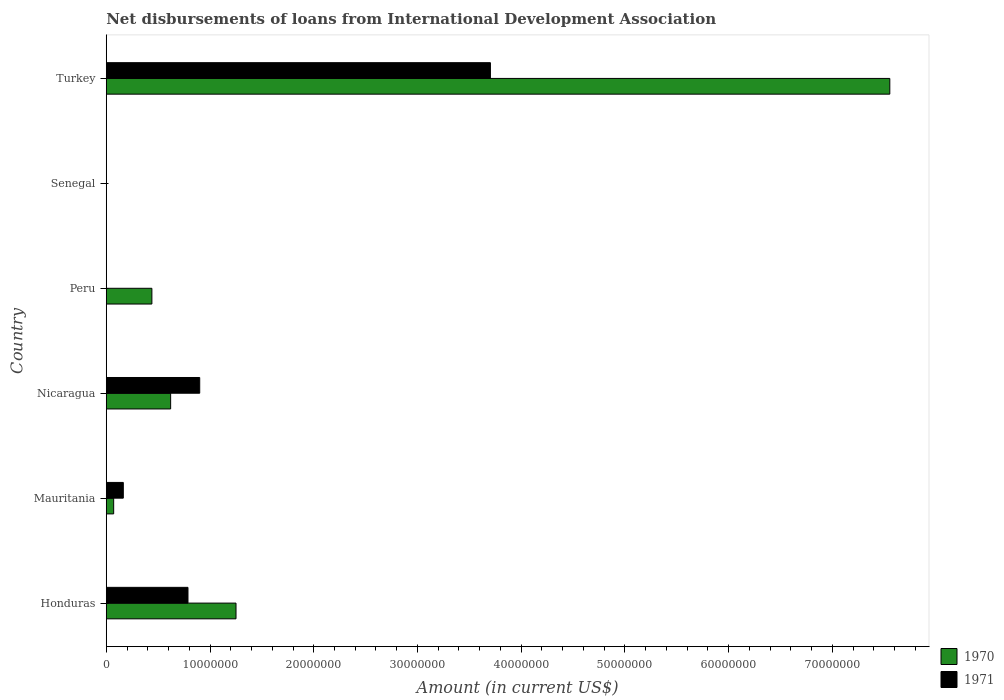Are the number of bars per tick equal to the number of legend labels?
Ensure brevity in your answer.  No. How many bars are there on the 6th tick from the top?
Keep it short and to the point. 2. In how many cases, is the number of bars for a given country not equal to the number of legend labels?
Your response must be concise. 2. What is the amount of loans disbursed in 1970 in Senegal?
Your answer should be compact. 0. Across all countries, what is the maximum amount of loans disbursed in 1971?
Offer a terse response. 3.70e+07. Across all countries, what is the minimum amount of loans disbursed in 1970?
Provide a short and direct response. 0. In which country was the amount of loans disbursed in 1970 maximum?
Provide a succinct answer. Turkey. What is the total amount of loans disbursed in 1970 in the graph?
Provide a short and direct response. 9.94e+07. What is the difference between the amount of loans disbursed in 1971 in Honduras and that in Turkey?
Your answer should be very brief. -2.92e+07. What is the difference between the amount of loans disbursed in 1970 in Nicaragua and the amount of loans disbursed in 1971 in Turkey?
Your response must be concise. -3.08e+07. What is the average amount of loans disbursed in 1971 per country?
Make the answer very short. 9.26e+06. What is the difference between the amount of loans disbursed in 1971 and amount of loans disbursed in 1970 in Honduras?
Offer a terse response. -4.63e+06. In how many countries, is the amount of loans disbursed in 1971 greater than 24000000 US$?
Your answer should be very brief. 1. What is the ratio of the amount of loans disbursed in 1970 in Nicaragua to that in Turkey?
Offer a very short reply. 0.08. What is the difference between the highest and the second highest amount of loans disbursed in 1970?
Ensure brevity in your answer.  6.30e+07. What is the difference between the highest and the lowest amount of loans disbursed in 1971?
Provide a short and direct response. 3.70e+07. In how many countries, is the amount of loans disbursed in 1971 greater than the average amount of loans disbursed in 1971 taken over all countries?
Provide a short and direct response. 1. How many countries are there in the graph?
Offer a very short reply. 6. Are the values on the major ticks of X-axis written in scientific E-notation?
Keep it short and to the point. No. Does the graph contain any zero values?
Give a very brief answer. Yes. Does the graph contain grids?
Keep it short and to the point. No. How many legend labels are there?
Offer a very short reply. 2. What is the title of the graph?
Provide a short and direct response. Net disbursements of loans from International Development Association. Does "1981" appear as one of the legend labels in the graph?
Keep it short and to the point. No. What is the Amount (in current US$) in 1970 in Honduras?
Ensure brevity in your answer.  1.25e+07. What is the Amount (in current US$) of 1971 in Honduras?
Ensure brevity in your answer.  7.88e+06. What is the Amount (in current US$) of 1970 in Mauritania?
Make the answer very short. 7.15e+05. What is the Amount (in current US$) of 1971 in Mauritania?
Your answer should be very brief. 1.64e+06. What is the Amount (in current US$) of 1970 in Nicaragua?
Offer a very short reply. 6.21e+06. What is the Amount (in current US$) in 1971 in Nicaragua?
Provide a short and direct response. 9.01e+06. What is the Amount (in current US$) in 1970 in Peru?
Make the answer very short. 4.40e+06. What is the Amount (in current US$) in 1970 in Turkey?
Keep it short and to the point. 7.55e+07. What is the Amount (in current US$) of 1971 in Turkey?
Your answer should be compact. 3.70e+07. Across all countries, what is the maximum Amount (in current US$) of 1970?
Make the answer very short. 7.55e+07. Across all countries, what is the maximum Amount (in current US$) of 1971?
Your answer should be very brief. 3.70e+07. Across all countries, what is the minimum Amount (in current US$) in 1970?
Your response must be concise. 0. Across all countries, what is the minimum Amount (in current US$) in 1971?
Make the answer very short. 0. What is the total Amount (in current US$) of 1970 in the graph?
Ensure brevity in your answer.  9.94e+07. What is the total Amount (in current US$) in 1971 in the graph?
Offer a terse response. 5.56e+07. What is the difference between the Amount (in current US$) of 1970 in Honduras and that in Mauritania?
Your response must be concise. 1.18e+07. What is the difference between the Amount (in current US$) of 1971 in Honduras and that in Mauritania?
Keep it short and to the point. 6.23e+06. What is the difference between the Amount (in current US$) in 1970 in Honduras and that in Nicaragua?
Ensure brevity in your answer.  6.30e+06. What is the difference between the Amount (in current US$) of 1971 in Honduras and that in Nicaragua?
Offer a very short reply. -1.13e+06. What is the difference between the Amount (in current US$) in 1970 in Honduras and that in Peru?
Keep it short and to the point. 8.11e+06. What is the difference between the Amount (in current US$) in 1970 in Honduras and that in Turkey?
Give a very brief answer. -6.30e+07. What is the difference between the Amount (in current US$) in 1971 in Honduras and that in Turkey?
Provide a short and direct response. -2.92e+07. What is the difference between the Amount (in current US$) in 1970 in Mauritania and that in Nicaragua?
Make the answer very short. -5.49e+06. What is the difference between the Amount (in current US$) of 1971 in Mauritania and that in Nicaragua?
Give a very brief answer. -7.36e+06. What is the difference between the Amount (in current US$) of 1970 in Mauritania and that in Peru?
Provide a succinct answer. -3.68e+06. What is the difference between the Amount (in current US$) of 1970 in Mauritania and that in Turkey?
Give a very brief answer. -7.48e+07. What is the difference between the Amount (in current US$) in 1971 in Mauritania and that in Turkey?
Your answer should be very brief. -3.54e+07. What is the difference between the Amount (in current US$) in 1970 in Nicaragua and that in Peru?
Give a very brief answer. 1.81e+06. What is the difference between the Amount (in current US$) of 1970 in Nicaragua and that in Turkey?
Offer a terse response. -6.93e+07. What is the difference between the Amount (in current US$) of 1971 in Nicaragua and that in Turkey?
Provide a short and direct response. -2.80e+07. What is the difference between the Amount (in current US$) in 1970 in Peru and that in Turkey?
Provide a succinct answer. -7.11e+07. What is the difference between the Amount (in current US$) in 1970 in Honduras and the Amount (in current US$) in 1971 in Mauritania?
Offer a terse response. 1.09e+07. What is the difference between the Amount (in current US$) in 1970 in Honduras and the Amount (in current US$) in 1971 in Nicaragua?
Your answer should be very brief. 3.50e+06. What is the difference between the Amount (in current US$) of 1970 in Honduras and the Amount (in current US$) of 1971 in Turkey?
Your answer should be very brief. -2.45e+07. What is the difference between the Amount (in current US$) of 1970 in Mauritania and the Amount (in current US$) of 1971 in Nicaragua?
Give a very brief answer. -8.30e+06. What is the difference between the Amount (in current US$) of 1970 in Mauritania and the Amount (in current US$) of 1971 in Turkey?
Offer a terse response. -3.63e+07. What is the difference between the Amount (in current US$) in 1970 in Nicaragua and the Amount (in current US$) in 1971 in Turkey?
Your answer should be compact. -3.08e+07. What is the difference between the Amount (in current US$) in 1970 in Peru and the Amount (in current US$) in 1971 in Turkey?
Your answer should be compact. -3.26e+07. What is the average Amount (in current US$) in 1970 per country?
Provide a short and direct response. 1.66e+07. What is the average Amount (in current US$) of 1971 per country?
Provide a succinct answer. 9.26e+06. What is the difference between the Amount (in current US$) in 1970 and Amount (in current US$) in 1971 in Honduras?
Your response must be concise. 4.63e+06. What is the difference between the Amount (in current US$) of 1970 and Amount (in current US$) of 1971 in Mauritania?
Your answer should be compact. -9.30e+05. What is the difference between the Amount (in current US$) of 1970 and Amount (in current US$) of 1971 in Nicaragua?
Make the answer very short. -2.80e+06. What is the difference between the Amount (in current US$) of 1970 and Amount (in current US$) of 1971 in Turkey?
Your answer should be very brief. 3.85e+07. What is the ratio of the Amount (in current US$) in 1970 in Honduras to that in Mauritania?
Give a very brief answer. 17.49. What is the ratio of the Amount (in current US$) in 1971 in Honduras to that in Mauritania?
Provide a succinct answer. 4.79. What is the ratio of the Amount (in current US$) of 1970 in Honduras to that in Nicaragua?
Offer a very short reply. 2.02. What is the ratio of the Amount (in current US$) in 1971 in Honduras to that in Nicaragua?
Keep it short and to the point. 0.87. What is the ratio of the Amount (in current US$) in 1970 in Honduras to that in Peru?
Offer a terse response. 2.84. What is the ratio of the Amount (in current US$) of 1970 in Honduras to that in Turkey?
Your answer should be very brief. 0.17. What is the ratio of the Amount (in current US$) in 1971 in Honduras to that in Turkey?
Your response must be concise. 0.21. What is the ratio of the Amount (in current US$) in 1970 in Mauritania to that in Nicaragua?
Offer a very short reply. 0.12. What is the ratio of the Amount (in current US$) of 1971 in Mauritania to that in Nicaragua?
Keep it short and to the point. 0.18. What is the ratio of the Amount (in current US$) in 1970 in Mauritania to that in Peru?
Give a very brief answer. 0.16. What is the ratio of the Amount (in current US$) in 1970 in Mauritania to that in Turkey?
Ensure brevity in your answer.  0.01. What is the ratio of the Amount (in current US$) of 1971 in Mauritania to that in Turkey?
Provide a short and direct response. 0.04. What is the ratio of the Amount (in current US$) of 1970 in Nicaragua to that in Peru?
Give a very brief answer. 1.41. What is the ratio of the Amount (in current US$) in 1970 in Nicaragua to that in Turkey?
Make the answer very short. 0.08. What is the ratio of the Amount (in current US$) of 1971 in Nicaragua to that in Turkey?
Your answer should be very brief. 0.24. What is the ratio of the Amount (in current US$) in 1970 in Peru to that in Turkey?
Your response must be concise. 0.06. What is the difference between the highest and the second highest Amount (in current US$) in 1970?
Provide a succinct answer. 6.30e+07. What is the difference between the highest and the second highest Amount (in current US$) in 1971?
Keep it short and to the point. 2.80e+07. What is the difference between the highest and the lowest Amount (in current US$) in 1970?
Your response must be concise. 7.55e+07. What is the difference between the highest and the lowest Amount (in current US$) of 1971?
Make the answer very short. 3.70e+07. 